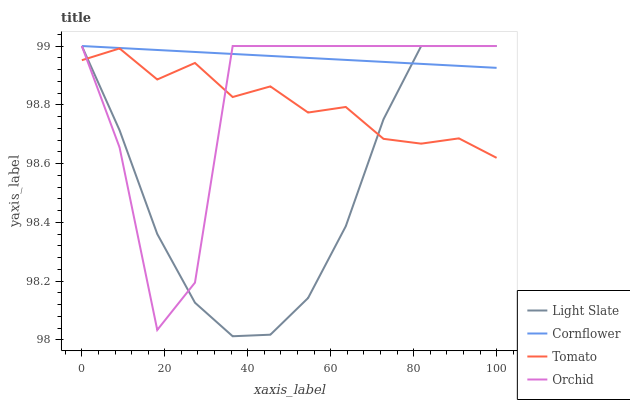Does Light Slate have the minimum area under the curve?
Answer yes or no. Yes. Does Cornflower have the maximum area under the curve?
Answer yes or no. Yes. Does Tomato have the minimum area under the curve?
Answer yes or no. No. Does Tomato have the maximum area under the curve?
Answer yes or no. No. Is Cornflower the smoothest?
Answer yes or no. Yes. Is Orchid the roughest?
Answer yes or no. Yes. Is Tomato the smoothest?
Answer yes or no. No. Is Tomato the roughest?
Answer yes or no. No. Does Light Slate have the lowest value?
Answer yes or no. Yes. Does Tomato have the lowest value?
Answer yes or no. No. Does Orchid have the highest value?
Answer yes or no. Yes. Does Tomato have the highest value?
Answer yes or no. No. Is Tomato less than Cornflower?
Answer yes or no. Yes. Is Cornflower greater than Tomato?
Answer yes or no. Yes. Does Orchid intersect Tomato?
Answer yes or no. Yes. Is Orchid less than Tomato?
Answer yes or no. No. Is Orchid greater than Tomato?
Answer yes or no. No. Does Tomato intersect Cornflower?
Answer yes or no. No. 